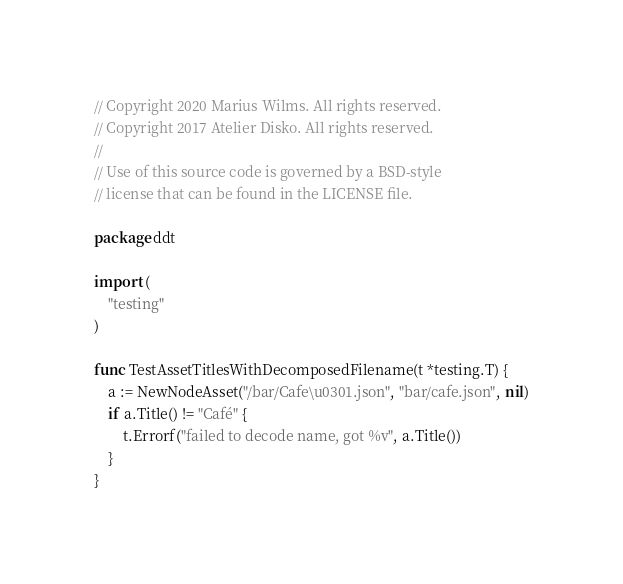Convert code to text. <code><loc_0><loc_0><loc_500><loc_500><_Go_>// Copyright 2020 Marius Wilms. All rights reserved.
// Copyright 2017 Atelier Disko. All rights reserved.
//
// Use of this source code is governed by a BSD-style
// license that can be found in the LICENSE file.

package ddt

import (
	"testing"
)

func TestAssetTitlesWithDecomposedFilename(t *testing.T) {
	a := NewNodeAsset("/bar/Cafe\u0301.json", "bar/cafe.json", nil)
	if a.Title() != "Café" {
		t.Errorf("failed to decode name, got %v", a.Title())
	}
}
</code> 